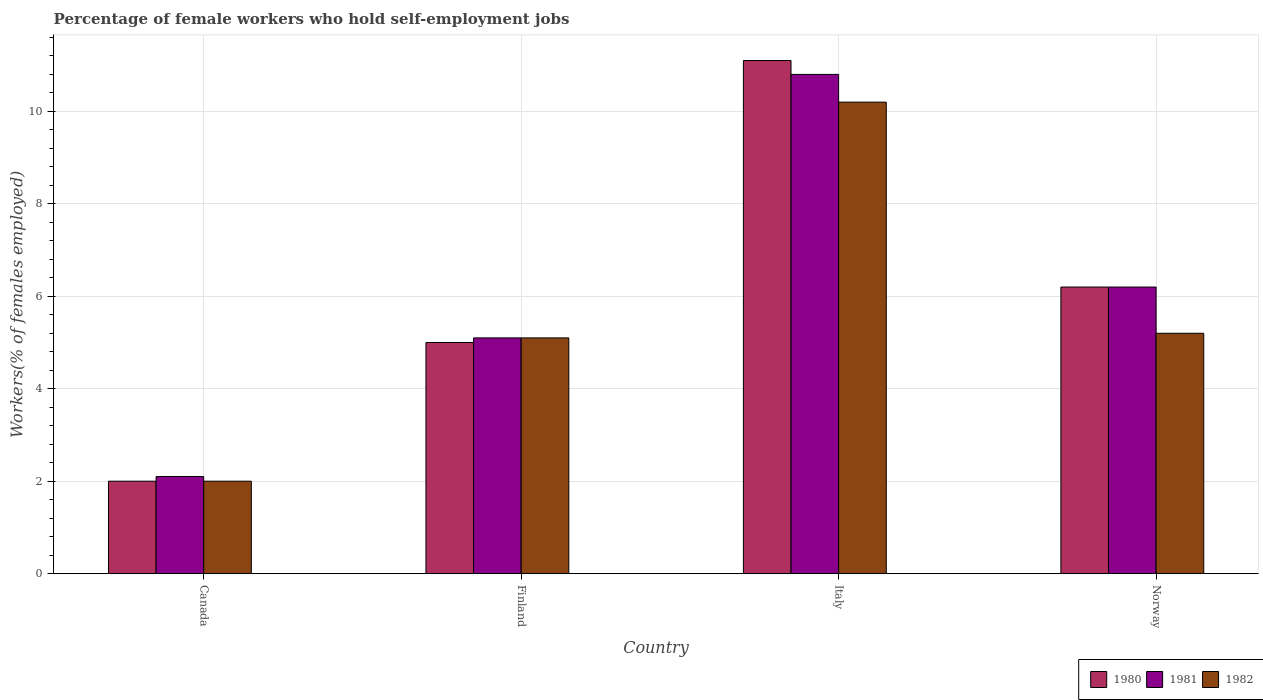How many different coloured bars are there?
Provide a succinct answer. 3. How many bars are there on the 1st tick from the left?
Your answer should be very brief. 3. What is the label of the 4th group of bars from the left?
Ensure brevity in your answer.  Norway. In how many cases, is the number of bars for a given country not equal to the number of legend labels?
Your answer should be compact. 0. What is the percentage of self-employed female workers in 1982 in Norway?
Offer a terse response. 5.2. Across all countries, what is the maximum percentage of self-employed female workers in 1982?
Give a very brief answer. 10.2. Across all countries, what is the minimum percentage of self-employed female workers in 1981?
Ensure brevity in your answer.  2.1. In which country was the percentage of self-employed female workers in 1980 maximum?
Offer a very short reply. Italy. In which country was the percentage of self-employed female workers in 1980 minimum?
Offer a very short reply. Canada. What is the total percentage of self-employed female workers in 1982 in the graph?
Offer a very short reply. 22.5. What is the difference between the percentage of self-employed female workers in 1981 in Finland and that in Italy?
Your answer should be compact. -5.7. What is the difference between the percentage of self-employed female workers in 1980 in Norway and the percentage of self-employed female workers in 1981 in Canada?
Your answer should be very brief. 4.1. What is the average percentage of self-employed female workers in 1981 per country?
Your response must be concise. 6.05. What is the difference between the percentage of self-employed female workers of/in 1980 and percentage of self-employed female workers of/in 1981 in Italy?
Your response must be concise. 0.3. In how many countries, is the percentage of self-employed female workers in 1981 greater than 9.6 %?
Your answer should be very brief. 1. What is the ratio of the percentage of self-employed female workers in 1981 in Canada to that in Norway?
Provide a short and direct response. 0.34. Is the difference between the percentage of self-employed female workers in 1980 in Canada and Norway greater than the difference between the percentage of self-employed female workers in 1981 in Canada and Norway?
Offer a terse response. No. What is the difference between the highest and the second highest percentage of self-employed female workers in 1981?
Your answer should be compact. 5.7. What is the difference between the highest and the lowest percentage of self-employed female workers in 1982?
Make the answer very short. 8.2. In how many countries, is the percentage of self-employed female workers in 1980 greater than the average percentage of self-employed female workers in 1980 taken over all countries?
Ensure brevity in your answer.  2. What does the 2nd bar from the left in Norway represents?
Ensure brevity in your answer.  1981. Is it the case that in every country, the sum of the percentage of self-employed female workers in 1980 and percentage of self-employed female workers in 1982 is greater than the percentage of self-employed female workers in 1981?
Make the answer very short. Yes. How many bars are there?
Your response must be concise. 12. Are all the bars in the graph horizontal?
Ensure brevity in your answer.  No. Are the values on the major ticks of Y-axis written in scientific E-notation?
Offer a terse response. No. Does the graph contain any zero values?
Provide a succinct answer. No. Does the graph contain grids?
Provide a short and direct response. Yes. What is the title of the graph?
Provide a succinct answer. Percentage of female workers who hold self-employment jobs. What is the label or title of the X-axis?
Keep it short and to the point. Country. What is the label or title of the Y-axis?
Keep it short and to the point. Workers(% of females employed). What is the Workers(% of females employed) in 1981 in Canada?
Provide a short and direct response. 2.1. What is the Workers(% of females employed) in 1980 in Finland?
Your answer should be compact. 5. What is the Workers(% of females employed) in 1981 in Finland?
Your response must be concise. 5.1. What is the Workers(% of females employed) in 1982 in Finland?
Your answer should be compact. 5.1. What is the Workers(% of females employed) of 1980 in Italy?
Provide a succinct answer. 11.1. What is the Workers(% of females employed) in 1981 in Italy?
Provide a succinct answer. 10.8. What is the Workers(% of females employed) in 1982 in Italy?
Ensure brevity in your answer.  10.2. What is the Workers(% of females employed) of 1980 in Norway?
Your answer should be very brief. 6.2. What is the Workers(% of females employed) of 1981 in Norway?
Provide a short and direct response. 6.2. What is the Workers(% of females employed) in 1982 in Norway?
Your answer should be compact. 5.2. Across all countries, what is the maximum Workers(% of females employed) in 1980?
Your response must be concise. 11.1. Across all countries, what is the maximum Workers(% of females employed) in 1981?
Offer a terse response. 10.8. Across all countries, what is the maximum Workers(% of females employed) of 1982?
Provide a short and direct response. 10.2. Across all countries, what is the minimum Workers(% of females employed) of 1981?
Offer a very short reply. 2.1. Across all countries, what is the minimum Workers(% of females employed) of 1982?
Keep it short and to the point. 2. What is the total Workers(% of females employed) in 1980 in the graph?
Offer a terse response. 24.3. What is the total Workers(% of females employed) of 1981 in the graph?
Keep it short and to the point. 24.2. What is the total Workers(% of females employed) in 1982 in the graph?
Offer a terse response. 22.5. What is the difference between the Workers(% of females employed) of 1980 in Canada and that in Norway?
Provide a succinct answer. -4.2. What is the difference between the Workers(% of females employed) in 1982 in Canada and that in Norway?
Keep it short and to the point. -3.2. What is the difference between the Workers(% of females employed) in 1980 in Finland and that in Norway?
Your response must be concise. -1.2. What is the difference between the Workers(% of females employed) of 1980 in Italy and that in Norway?
Offer a terse response. 4.9. What is the difference between the Workers(% of females employed) in 1981 in Italy and that in Norway?
Ensure brevity in your answer.  4.6. What is the difference between the Workers(% of females employed) of 1980 in Canada and the Workers(% of females employed) of 1981 in Finland?
Offer a very short reply. -3.1. What is the difference between the Workers(% of females employed) in 1981 in Canada and the Workers(% of females employed) in 1982 in Finland?
Provide a succinct answer. -3. What is the difference between the Workers(% of females employed) in 1980 in Canada and the Workers(% of females employed) in 1982 in Italy?
Your answer should be very brief. -8.2. What is the difference between the Workers(% of females employed) in 1981 in Canada and the Workers(% of females employed) in 1982 in Italy?
Your response must be concise. -8.1. What is the difference between the Workers(% of females employed) in 1980 in Finland and the Workers(% of females employed) in 1981 in Italy?
Provide a succinct answer. -5.8. What is the difference between the Workers(% of females employed) of 1980 in Finland and the Workers(% of females employed) of 1981 in Norway?
Keep it short and to the point. -1.2. What is the difference between the Workers(% of females employed) in 1981 in Finland and the Workers(% of females employed) in 1982 in Norway?
Ensure brevity in your answer.  -0.1. What is the difference between the Workers(% of females employed) in 1981 in Italy and the Workers(% of females employed) in 1982 in Norway?
Give a very brief answer. 5.6. What is the average Workers(% of females employed) in 1980 per country?
Offer a terse response. 6.08. What is the average Workers(% of females employed) in 1981 per country?
Your answer should be compact. 6.05. What is the average Workers(% of females employed) in 1982 per country?
Offer a very short reply. 5.62. What is the difference between the Workers(% of females employed) of 1980 and Workers(% of females employed) of 1982 in Canada?
Your answer should be very brief. 0. What is the difference between the Workers(% of females employed) in 1980 and Workers(% of females employed) in 1981 in Finland?
Offer a terse response. -0.1. What is the difference between the Workers(% of females employed) of 1980 and Workers(% of females employed) of 1982 in Finland?
Offer a terse response. -0.1. What is the difference between the Workers(% of females employed) of 1980 and Workers(% of females employed) of 1981 in Italy?
Your answer should be very brief. 0.3. What is the difference between the Workers(% of females employed) in 1981 and Workers(% of females employed) in 1982 in Italy?
Your answer should be very brief. 0.6. What is the difference between the Workers(% of females employed) of 1980 and Workers(% of females employed) of 1982 in Norway?
Ensure brevity in your answer.  1. What is the ratio of the Workers(% of females employed) of 1981 in Canada to that in Finland?
Provide a succinct answer. 0.41. What is the ratio of the Workers(% of females employed) of 1982 in Canada to that in Finland?
Your answer should be very brief. 0.39. What is the ratio of the Workers(% of females employed) in 1980 in Canada to that in Italy?
Make the answer very short. 0.18. What is the ratio of the Workers(% of females employed) of 1981 in Canada to that in Italy?
Ensure brevity in your answer.  0.19. What is the ratio of the Workers(% of females employed) of 1982 in Canada to that in Italy?
Your answer should be very brief. 0.2. What is the ratio of the Workers(% of females employed) of 1980 in Canada to that in Norway?
Give a very brief answer. 0.32. What is the ratio of the Workers(% of females employed) of 1981 in Canada to that in Norway?
Provide a short and direct response. 0.34. What is the ratio of the Workers(% of females employed) of 1982 in Canada to that in Norway?
Ensure brevity in your answer.  0.38. What is the ratio of the Workers(% of females employed) in 1980 in Finland to that in Italy?
Your answer should be very brief. 0.45. What is the ratio of the Workers(% of females employed) in 1981 in Finland to that in Italy?
Give a very brief answer. 0.47. What is the ratio of the Workers(% of females employed) of 1982 in Finland to that in Italy?
Provide a succinct answer. 0.5. What is the ratio of the Workers(% of females employed) of 1980 in Finland to that in Norway?
Ensure brevity in your answer.  0.81. What is the ratio of the Workers(% of females employed) of 1981 in Finland to that in Norway?
Offer a terse response. 0.82. What is the ratio of the Workers(% of females employed) of 1982 in Finland to that in Norway?
Your response must be concise. 0.98. What is the ratio of the Workers(% of females employed) in 1980 in Italy to that in Norway?
Keep it short and to the point. 1.79. What is the ratio of the Workers(% of females employed) of 1981 in Italy to that in Norway?
Offer a terse response. 1.74. What is the ratio of the Workers(% of females employed) in 1982 in Italy to that in Norway?
Your response must be concise. 1.96. What is the difference between the highest and the second highest Workers(% of females employed) in 1982?
Give a very brief answer. 5. What is the difference between the highest and the lowest Workers(% of females employed) in 1981?
Offer a very short reply. 8.7. What is the difference between the highest and the lowest Workers(% of females employed) of 1982?
Your response must be concise. 8.2. 